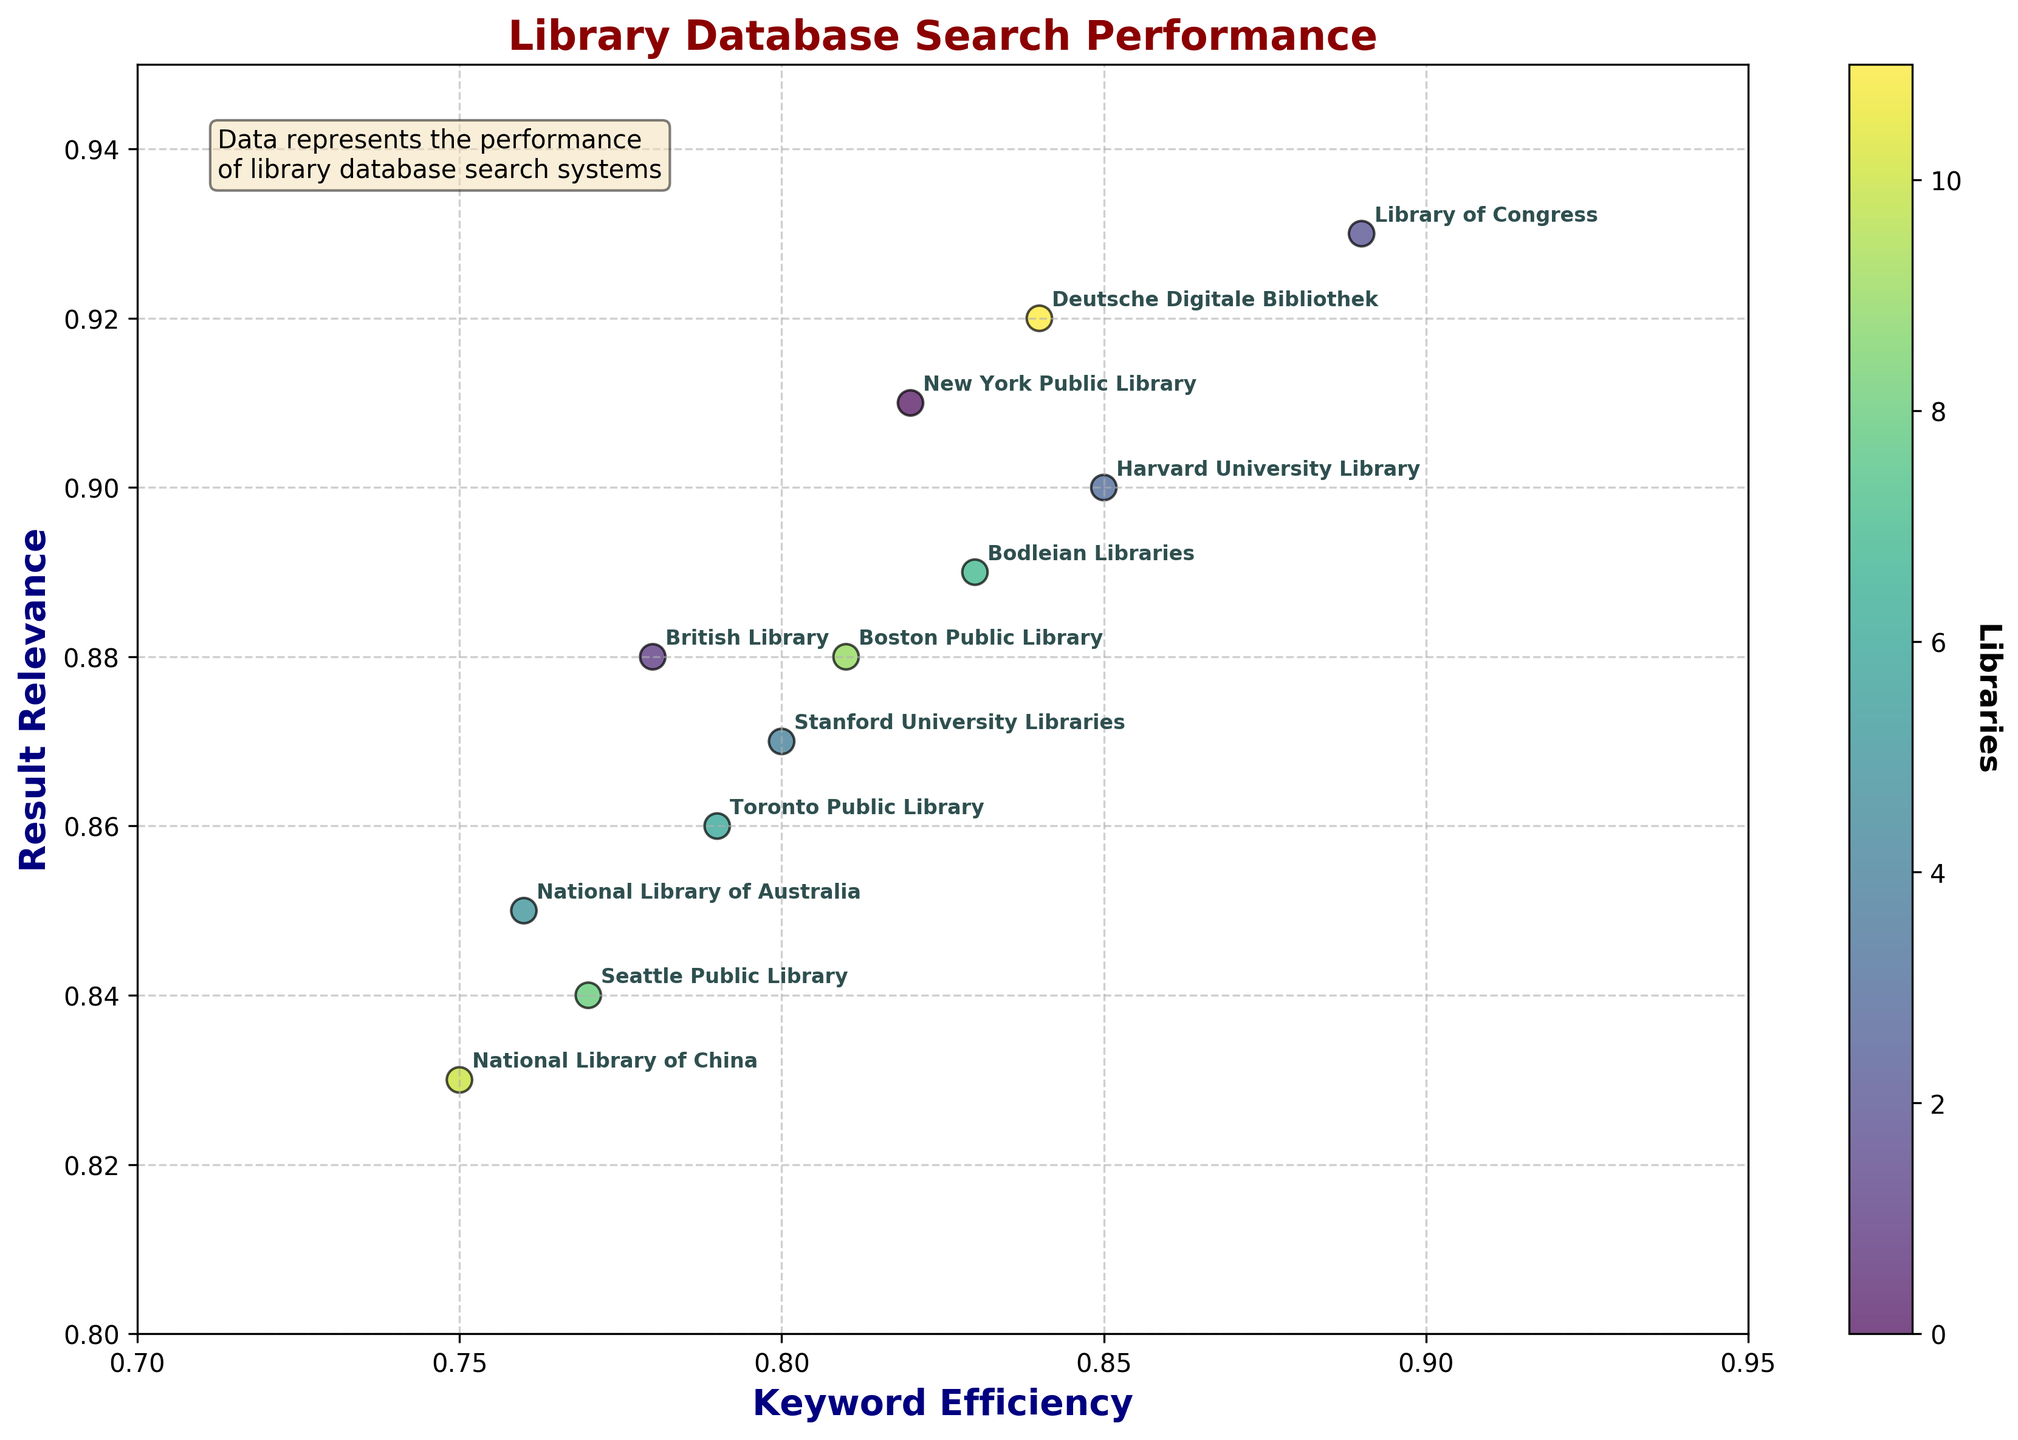What is the title of the figure? The title is typically placed at the top of the figure and it describes the main subject of the plot. It helps viewers quickly understand what the figure is about.
Answer: Library Database Search Performance Which library has the highest Keyword Efficiency? To find the library with the highest Keyword Efficiency, look for the highest value on the x-axis since Keyword Efficiency is represented by the x-axis.
Answer: Library of Congress What are the x-axis and y-axis labels in the figure? The x-axis label represents Keyword Efficiency, and the y-axis label represents Result Relevance. These labels help identify what each axis represents in the plot.
Answer: Keyword Efficiency, Result Relevance Which libraries have a Result Relevance above 0.90? Result Relevance is represented on the y-axis. Libraries above 0.90 can be seen by identifying points higher than this value on the y-axis.
Answer: New York Public Library, Library of Congress, Harvard University Library, Deutsche Digitale Bibliothek Which library has the lowest Result Relevance and what is its value? To find the library with the lowest Result Relevance, look for the point that is lowest on the y-axis, and check its corresponding label.
Answer: National Library of China, 0.83 Which library has both high Keyword Efficiency and high Result Relevance? Looking for a point that is positioned high on both the x-axis and y-axis will help identify the library with both high Keyword Efficiency and high Result Relevance.
Answer: Library of Congress What is the range of the Keyword Efficiency shown in the figure? The x-axis limits can be checked to see the span of Keyword Efficiency values.
Answer: 0.7 to 0.95 How do Keyword Efficiency and Result Relevance compare for the British Library and Stanford University Libraries? Check the x and y coordinates for both libraries and compare both the Keyword Efficiency and Result Relevance of each.
Answer: British Library: 0.78 (KE), 0.88 (RR); Stanford University Libraries: 0.80 (KE), 0.87 (RR) Which library represents the median Result Relevance value and what is that value? Arrange the Result Relevance values and find the middle one. The median is the value separating the higher half from the lower half.
Answer: Seattle Public Library, 0.84 Which two libraries have the closest values in both Keyword Efficiency and Result Relevance? Observe pairs of points that are nearest to each other in both x-axis and y-axis values to determine the closest libraries.
Answer: Stanford University Libraries and British Library 